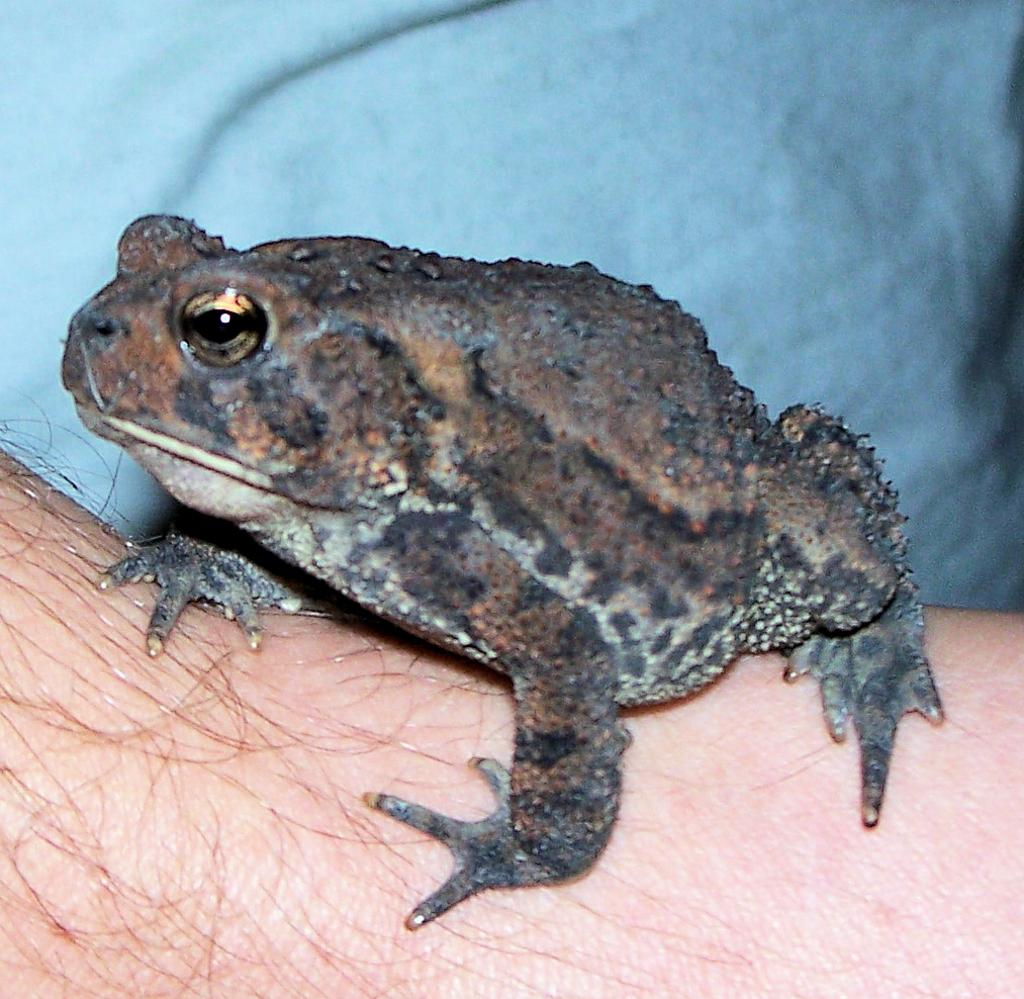What animal is present in the image? There is a frog in the image. What is the color of the surface the frog is on? The surface the frog is on is cream in color. What type of detail can be seen in the image? There are hairs visible in the image. What can be seen in the background of the image? There is a blue cloth in the background of the image. What type of mine can be seen in the image? There is no mine present in the image. What color is the copper in the image? There is no copper present in the image. 